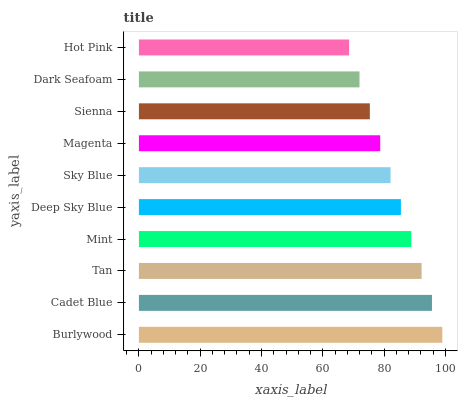Is Hot Pink the minimum?
Answer yes or no. Yes. Is Burlywood the maximum?
Answer yes or no. Yes. Is Cadet Blue the minimum?
Answer yes or no. No. Is Cadet Blue the maximum?
Answer yes or no. No. Is Burlywood greater than Cadet Blue?
Answer yes or no. Yes. Is Cadet Blue less than Burlywood?
Answer yes or no. Yes. Is Cadet Blue greater than Burlywood?
Answer yes or no. No. Is Burlywood less than Cadet Blue?
Answer yes or no. No. Is Deep Sky Blue the high median?
Answer yes or no. Yes. Is Sky Blue the low median?
Answer yes or no. Yes. Is Magenta the high median?
Answer yes or no. No. Is Burlywood the low median?
Answer yes or no. No. 